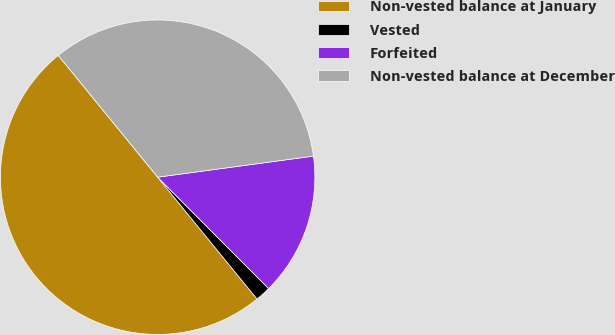<chart> <loc_0><loc_0><loc_500><loc_500><pie_chart><fcel>Non-vested balance at January<fcel>Vested<fcel>Forfeited<fcel>Non-vested balance at December<nl><fcel>50.0%<fcel>1.58%<fcel>14.67%<fcel>33.75%<nl></chart> 